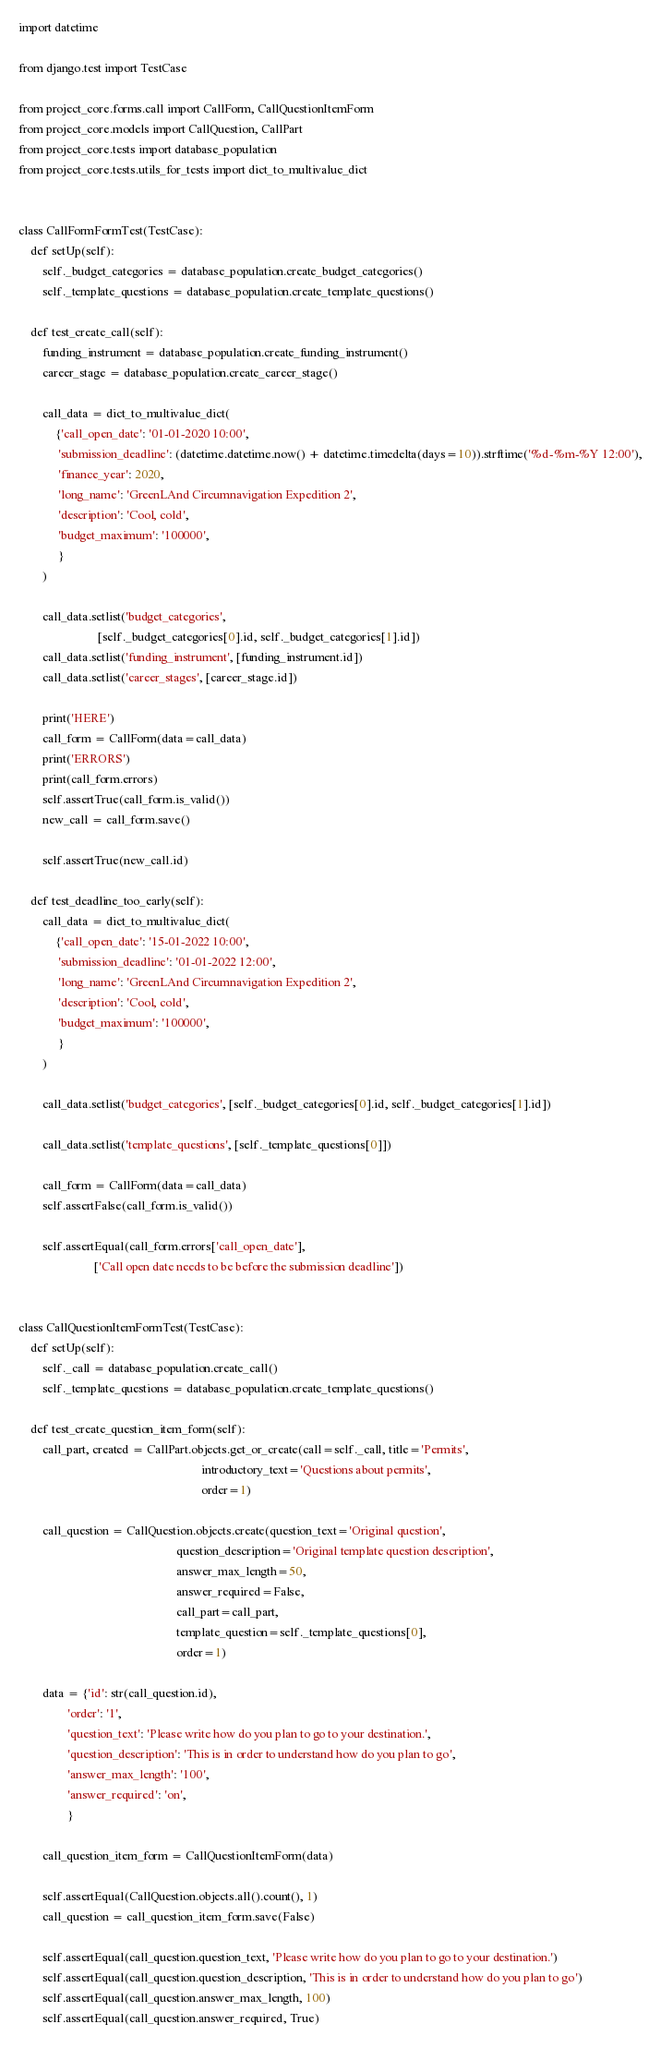<code> <loc_0><loc_0><loc_500><loc_500><_Python_>import datetime

from django.test import TestCase

from project_core.forms.call import CallForm, CallQuestionItemForm
from project_core.models import CallQuestion, CallPart
from project_core.tests import database_population
from project_core.tests.utils_for_tests import dict_to_multivalue_dict


class CallFormFormTest(TestCase):
    def setUp(self):
        self._budget_categories = database_population.create_budget_categories()
        self._template_questions = database_population.create_template_questions()

    def test_create_call(self):
        funding_instrument = database_population.create_funding_instrument()
        career_stage = database_population.create_career_stage()

        call_data = dict_to_multivalue_dict(
            {'call_open_date': '01-01-2020 10:00',
             'submission_deadline': (datetime.datetime.now() + datetime.timedelta(days=10)).strftime('%d-%m-%Y 12:00'),
             'finance_year': 2020,
             'long_name': 'GreenLAnd Circumnavigation Expedition 2',
             'description': 'Cool, cold',
             'budget_maximum': '100000',
             }
        )

        call_data.setlist('budget_categories',
                          [self._budget_categories[0].id, self._budget_categories[1].id])
        call_data.setlist('funding_instrument', [funding_instrument.id])
        call_data.setlist('career_stages', [career_stage.id])

        print('HERE')
        call_form = CallForm(data=call_data)
        print('ERRORS')
        print(call_form.errors)
        self.assertTrue(call_form.is_valid())
        new_call = call_form.save()

        self.assertTrue(new_call.id)

    def test_deadline_too_early(self):
        call_data = dict_to_multivalue_dict(
            {'call_open_date': '15-01-2022 10:00',
             'submission_deadline': '01-01-2022 12:00',
             'long_name': 'GreenLAnd Circumnavigation Expedition 2',
             'description': 'Cool, cold',
             'budget_maximum': '100000',
             }
        )

        call_data.setlist('budget_categories', [self._budget_categories[0].id, self._budget_categories[1].id])

        call_data.setlist('template_questions', [self._template_questions[0]])

        call_form = CallForm(data=call_data)
        self.assertFalse(call_form.is_valid())

        self.assertEqual(call_form.errors['call_open_date'],
                         ['Call open date needs to be before the submission deadline'])


class CallQuestionItemFormTest(TestCase):
    def setUp(self):
        self._call = database_population.create_call()
        self._template_questions = database_population.create_template_questions()

    def test_create_question_item_form(self):
        call_part, created = CallPart.objects.get_or_create(call=self._call, title='Permits',
                                                            introductory_text='Questions about permits',
                                                            order=1)

        call_question = CallQuestion.objects.create(question_text='Original question',
                                                    question_description='Original template question description',
                                                    answer_max_length=50,
                                                    answer_required=False,
                                                    call_part=call_part,
                                                    template_question=self._template_questions[0],
                                                    order=1)

        data = {'id': str(call_question.id),
                'order': '1',
                'question_text': 'Please write how do you plan to go to your destination.',
                'question_description': 'This is in order to understand how do you plan to go',
                'answer_max_length': '100',
                'answer_required': 'on',
                }

        call_question_item_form = CallQuestionItemForm(data)

        self.assertEqual(CallQuestion.objects.all().count(), 1)
        call_question = call_question_item_form.save(False)

        self.assertEqual(call_question.question_text, 'Please write how do you plan to go to your destination.')
        self.assertEqual(call_question.question_description, 'This is in order to understand how do you plan to go')
        self.assertEqual(call_question.answer_max_length, 100)
        self.assertEqual(call_question.answer_required, True)
</code> 